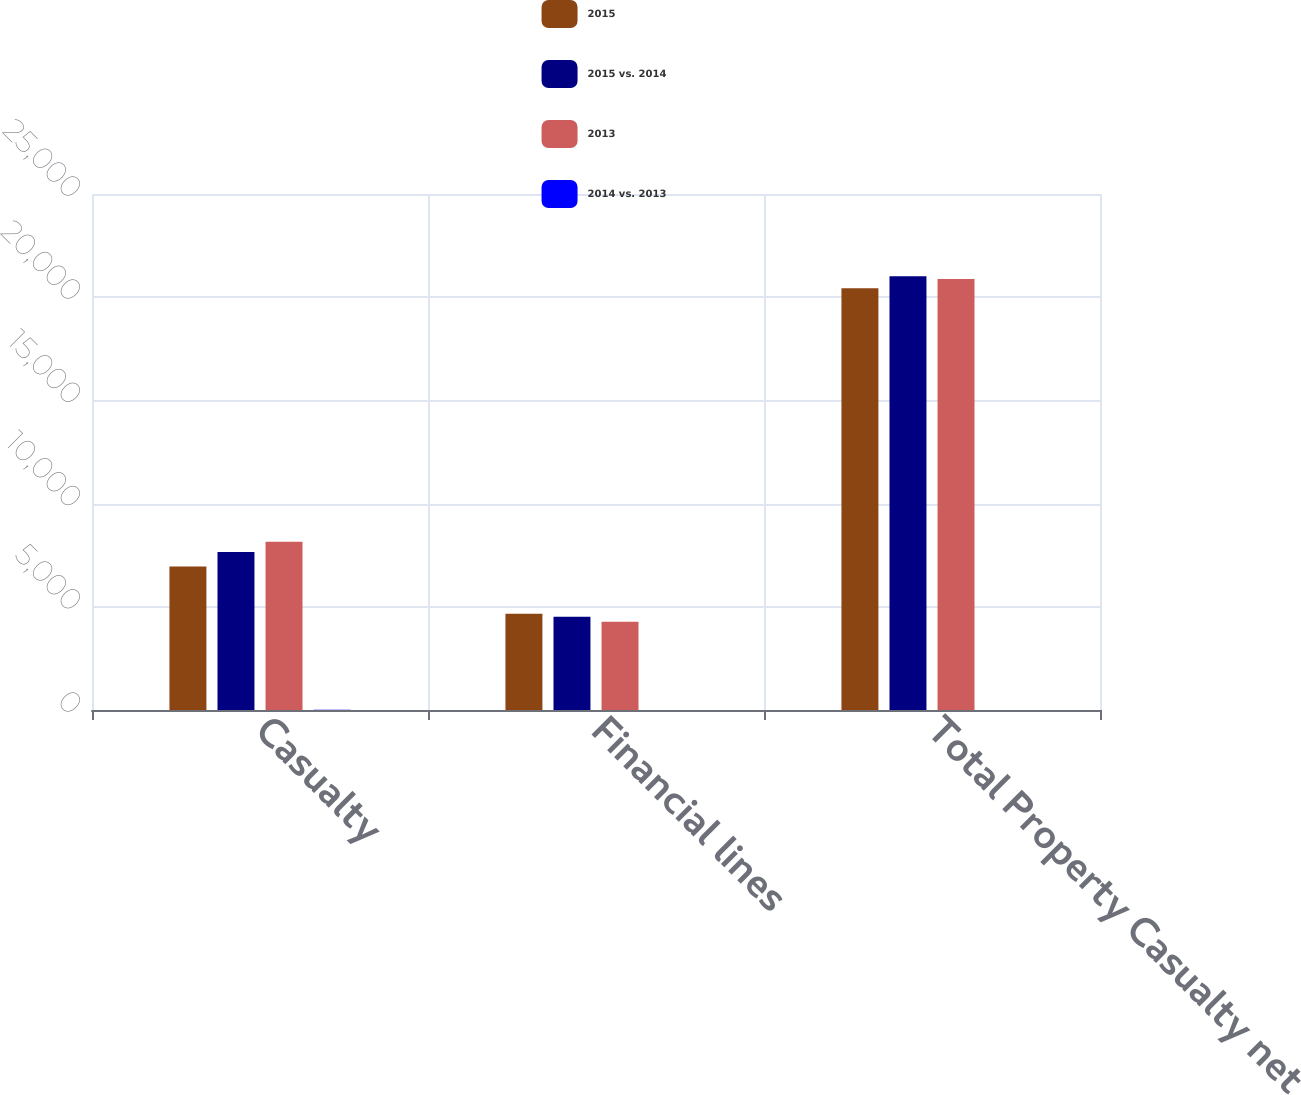<chart> <loc_0><loc_0><loc_500><loc_500><stacked_bar_chart><ecel><fcel>Casualty<fcel>Financial lines<fcel>Total Property Casualty net<nl><fcel>2015<fcel>6957<fcel>4666<fcel>20436<nl><fcel>2015 vs. 2014<fcel>7649<fcel>4521<fcel>21020<nl><fcel>2013<fcel>8154<fcel>4271<fcel>20880<nl><fcel>2014 vs. 2013<fcel>9<fcel>3<fcel>3<nl></chart> 